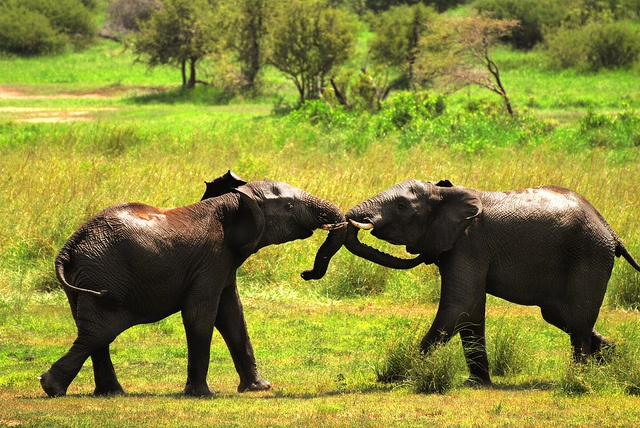Describe the objects in this image and their specific colors. I can see elephant in olive, black, and gray tones and elephant in olive, black, darkgreen, ivory, and tan tones in this image. 